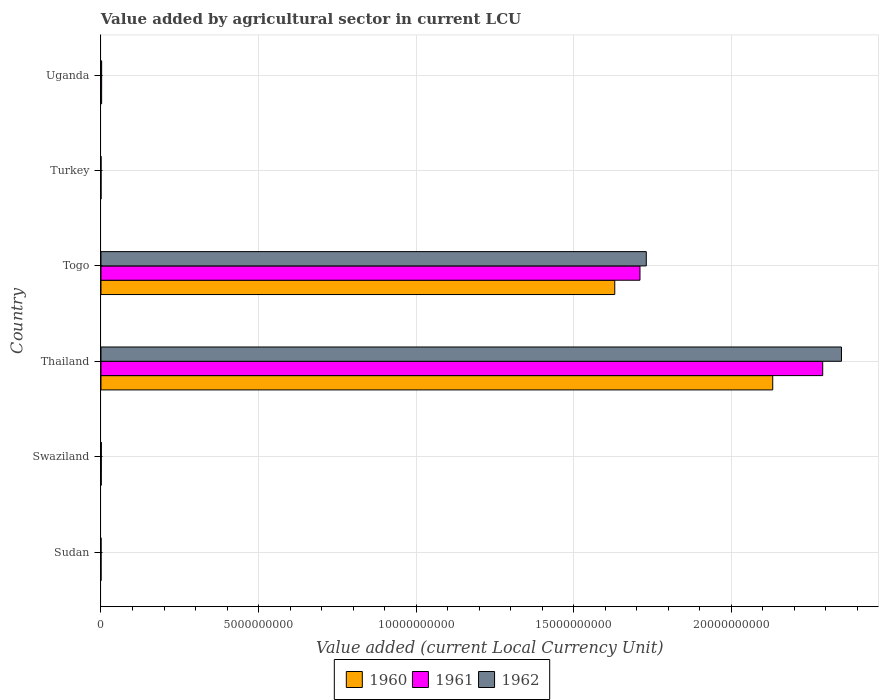How many different coloured bars are there?
Your answer should be very brief. 3. How many groups of bars are there?
Give a very brief answer. 6. Are the number of bars on each tick of the Y-axis equal?
Provide a succinct answer. Yes. How many bars are there on the 6th tick from the top?
Provide a succinct answer. 3. What is the label of the 4th group of bars from the top?
Make the answer very short. Thailand. In how many cases, is the number of bars for a given country not equal to the number of legend labels?
Make the answer very short. 0. What is the value added by agricultural sector in 1960 in Uganda?
Provide a short and direct response. 2.01e+07. Across all countries, what is the maximum value added by agricultural sector in 1962?
Your answer should be very brief. 2.35e+1. Across all countries, what is the minimum value added by agricultural sector in 1961?
Ensure brevity in your answer.  3.72e+04. In which country was the value added by agricultural sector in 1962 maximum?
Your answer should be compact. Thailand. What is the total value added by agricultural sector in 1962 in the graph?
Ensure brevity in your answer.  4.08e+1. What is the difference between the value added by agricultural sector in 1961 in Sudan and that in Swaziland?
Your response must be concise. -9.08e+06. What is the difference between the value added by agricultural sector in 1962 in Uganda and the value added by agricultural sector in 1960 in Turkey?
Offer a terse response. 2.10e+07. What is the average value added by agricultural sector in 1961 per country?
Provide a succinct answer. 6.67e+09. What is the difference between the value added by agricultural sector in 1960 and value added by agricultural sector in 1961 in Togo?
Make the answer very short. -8.00e+08. What is the ratio of the value added by agricultural sector in 1961 in Sudan to that in Togo?
Provide a short and direct response. 1.282456042854219e-5. Is the value added by agricultural sector in 1960 in Swaziland less than that in Thailand?
Your answer should be compact. Yes. What is the difference between the highest and the second highest value added by agricultural sector in 1962?
Your answer should be very brief. 6.19e+09. What is the difference between the highest and the lowest value added by agricultural sector in 1962?
Keep it short and to the point. 2.35e+1. What does the 1st bar from the top in Togo represents?
Offer a terse response. 1962. What does the 1st bar from the bottom in Thailand represents?
Ensure brevity in your answer.  1960. Is it the case that in every country, the sum of the value added by agricultural sector in 1960 and value added by agricultural sector in 1961 is greater than the value added by agricultural sector in 1962?
Offer a terse response. Yes. How many bars are there?
Give a very brief answer. 18. How many countries are there in the graph?
Your answer should be very brief. 6. Are the values on the major ticks of X-axis written in scientific E-notation?
Provide a short and direct response. No. Does the graph contain any zero values?
Provide a succinct answer. No. Where does the legend appear in the graph?
Ensure brevity in your answer.  Bottom center. How many legend labels are there?
Your answer should be compact. 3. How are the legend labels stacked?
Provide a short and direct response. Horizontal. What is the title of the graph?
Give a very brief answer. Value added by agricultural sector in current LCU. Does "1992" appear as one of the legend labels in the graph?
Your response must be concise. No. What is the label or title of the X-axis?
Provide a short and direct response. Value added (current Local Currency Unit). What is the Value added (current Local Currency Unit) of 1960 in Sudan?
Keep it short and to the point. 2.02e+05. What is the Value added (current Local Currency Unit) in 1961 in Sudan?
Offer a terse response. 2.19e+05. What is the Value added (current Local Currency Unit) of 1962 in Sudan?
Offer a terse response. 2.31e+05. What is the Value added (current Local Currency Unit) of 1960 in Swaziland?
Your answer should be very brief. 7.90e+06. What is the Value added (current Local Currency Unit) in 1961 in Swaziland?
Keep it short and to the point. 9.30e+06. What is the Value added (current Local Currency Unit) of 1962 in Swaziland?
Your answer should be very brief. 1.14e+07. What is the Value added (current Local Currency Unit) of 1960 in Thailand?
Give a very brief answer. 2.13e+1. What is the Value added (current Local Currency Unit) of 1961 in Thailand?
Keep it short and to the point. 2.29e+1. What is the Value added (current Local Currency Unit) in 1962 in Thailand?
Your response must be concise. 2.35e+1. What is the Value added (current Local Currency Unit) in 1960 in Togo?
Your answer should be very brief. 1.63e+1. What is the Value added (current Local Currency Unit) in 1961 in Togo?
Make the answer very short. 1.71e+1. What is the Value added (current Local Currency Unit) of 1962 in Togo?
Your answer should be compact. 1.73e+1. What is the Value added (current Local Currency Unit) of 1960 in Turkey?
Provide a short and direct response. 3.74e+04. What is the Value added (current Local Currency Unit) in 1961 in Turkey?
Provide a short and direct response. 3.72e+04. What is the Value added (current Local Currency Unit) in 1962 in Turkey?
Offer a terse response. 4.24e+04. What is the Value added (current Local Currency Unit) of 1960 in Uganda?
Keep it short and to the point. 2.01e+07. What is the Value added (current Local Currency Unit) in 1961 in Uganda?
Ensure brevity in your answer.  2.10e+07. What is the Value added (current Local Currency Unit) in 1962 in Uganda?
Keep it short and to the point. 2.11e+07. Across all countries, what is the maximum Value added (current Local Currency Unit) in 1960?
Your answer should be compact. 2.13e+1. Across all countries, what is the maximum Value added (current Local Currency Unit) of 1961?
Your answer should be very brief. 2.29e+1. Across all countries, what is the maximum Value added (current Local Currency Unit) in 1962?
Ensure brevity in your answer.  2.35e+1. Across all countries, what is the minimum Value added (current Local Currency Unit) in 1960?
Ensure brevity in your answer.  3.74e+04. Across all countries, what is the minimum Value added (current Local Currency Unit) in 1961?
Your response must be concise. 3.72e+04. Across all countries, what is the minimum Value added (current Local Currency Unit) in 1962?
Give a very brief answer. 4.24e+04. What is the total Value added (current Local Currency Unit) of 1960 in the graph?
Make the answer very short. 3.76e+1. What is the total Value added (current Local Currency Unit) of 1961 in the graph?
Ensure brevity in your answer.  4.00e+1. What is the total Value added (current Local Currency Unit) in 1962 in the graph?
Ensure brevity in your answer.  4.08e+1. What is the difference between the Value added (current Local Currency Unit) in 1960 in Sudan and that in Swaziland?
Your response must be concise. -7.70e+06. What is the difference between the Value added (current Local Currency Unit) in 1961 in Sudan and that in Swaziland?
Give a very brief answer. -9.08e+06. What is the difference between the Value added (current Local Currency Unit) of 1962 in Sudan and that in Swaziland?
Give a very brief answer. -1.12e+07. What is the difference between the Value added (current Local Currency Unit) in 1960 in Sudan and that in Thailand?
Keep it short and to the point. -2.13e+1. What is the difference between the Value added (current Local Currency Unit) of 1961 in Sudan and that in Thailand?
Your response must be concise. -2.29e+1. What is the difference between the Value added (current Local Currency Unit) in 1962 in Sudan and that in Thailand?
Your response must be concise. -2.35e+1. What is the difference between the Value added (current Local Currency Unit) of 1960 in Sudan and that in Togo?
Offer a very short reply. -1.63e+1. What is the difference between the Value added (current Local Currency Unit) in 1961 in Sudan and that in Togo?
Your answer should be compact. -1.71e+1. What is the difference between the Value added (current Local Currency Unit) in 1962 in Sudan and that in Togo?
Your answer should be compact. -1.73e+1. What is the difference between the Value added (current Local Currency Unit) of 1960 in Sudan and that in Turkey?
Offer a terse response. 1.64e+05. What is the difference between the Value added (current Local Currency Unit) in 1961 in Sudan and that in Turkey?
Your answer should be very brief. 1.82e+05. What is the difference between the Value added (current Local Currency Unit) of 1962 in Sudan and that in Turkey?
Your answer should be very brief. 1.88e+05. What is the difference between the Value added (current Local Currency Unit) of 1960 in Sudan and that in Uganda?
Give a very brief answer. -1.99e+07. What is the difference between the Value added (current Local Currency Unit) in 1961 in Sudan and that in Uganda?
Provide a short and direct response. -2.08e+07. What is the difference between the Value added (current Local Currency Unit) in 1962 in Sudan and that in Uganda?
Give a very brief answer. -2.08e+07. What is the difference between the Value added (current Local Currency Unit) of 1960 in Swaziland and that in Thailand?
Your answer should be very brief. -2.13e+1. What is the difference between the Value added (current Local Currency Unit) in 1961 in Swaziland and that in Thailand?
Your answer should be very brief. -2.29e+1. What is the difference between the Value added (current Local Currency Unit) of 1962 in Swaziland and that in Thailand?
Your response must be concise. -2.35e+1. What is the difference between the Value added (current Local Currency Unit) in 1960 in Swaziland and that in Togo?
Your answer should be compact. -1.63e+1. What is the difference between the Value added (current Local Currency Unit) in 1961 in Swaziland and that in Togo?
Keep it short and to the point. -1.71e+1. What is the difference between the Value added (current Local Currency Unit) in 1962 in Swaziland and that in Togo?
Give a very brief answer. -1.73e+1. What is the difference between the Value added (current Local Currency Unit) of 1960 in Swaziland and that in Turkey?
Your response must be concise. 7.86e+06. What is the difference between the Value added (current Local Currency Unit) in 1961 in Swaziland and that in Turkey?
Give a very brief answer. 9.26e+06. What is the difference between the Value added (current Local Currency Unit) in 1962 in Swaziland and that in Turkey?
Make the answer very short. 1.14e+07. What is the difference between the Value added (current Local Currency Unit) in 1960 in Swaziland and that in Uganda?
Offer a very short reply. -1.22e+07. What is the difference between the Value added (current Local Currency Unit) in 1961 in Swaziland and that in Uganda?
Provide a short and direct response. -1.17e+07. What is the difference between the Value added (current Local Currency Unit) in 1962 in Swaziland and that in Uganda?
Give a very brief answer. -9.67e+06. What is the difference between the Value added (current Local Currency Unit) in 1960 in Thailand and that in Togo?
Provide a short and direct response. 5.01e+09. What is the difference between the Value added (current Local Currency Unit) in 1961 in Thailand and that in Togo?
Your answer should be compact. 5.80e+09. What is the difference between the Value added (current Local Currency Unit) of 1962 in Thailand and that in Togo?
Your answer should be compact. 6.19e+09. What is the difference between the Value added (current Local Currency Unit) in 1960 in Thailand and that in Turkey?
Provide a short and direct response. 2.13e+1. What is the difference between the Value added (current Local Currency Unit) in 1961 in Thailand and that in Turkey?
Your answer should be very brief. 2.29e+1. What is the difference between the Value added (current Local Currency Unit) of 1962 in Thailand and that in Turkey?
Give a very brief answer. 2.35e+1. What is the difference between the Value added (current Local Currency Unit) in 1960 in Thailand and that in Uganda?
Your answer should be compact. 2.13e+1. What is the difference between the Value added (current Local Currency Unit) in 1961 in Thailand and that in Uganda?
Make the answer very short. 2.29e+1. What is the difference between the Value added (current Local Currency Unit) of 1962 in Thailand and that in Uganda?
Provide a short and direct response. 2.35e+1. What is the difference between the Value added (current Local Currency Unit) in 1960 in Togo and that in Turkey?
Offer a very short reply. 1.63e+1. What is the difference between the Value added (current Local Currency Unit) in 1961 in Togo and that in Turkey?
Offer a terse response. 1.71e+1. What is the difference between the Value added (current Local Currency Unit) in 1962 in Togo and that in Turkey?
Give a very brief answer. 1.73e+1. What is the difference between the Value added (current Local Currency Unit) of 1960 in Togo and that in Uganda?
Make the answer very short. 1.63e+1. What is the difference between the Value added (current Local Currency Unit) of 1961 in Togo and that in Uganda?
Your response must be concise. 1.71e+1. What is the difference between the Value added (current Local Currency Unit) of 1962 in Togo and that in Uganda?
Your answer should be very brief. 1.73e+1. What is the difference between the Value added (current Local Currency Unit) in 1960 in Turkey and that in Uganda?
Your response must be concise. -2.01e+07. What is the difference between the Value added (current Local Currency Unit) in 1961 in Turkey and that in Uganda?
Offer a terse response. -2.10e+07. What is the difference between the Value added (current Local Currency Unit) of 1962 in Turkey and that in Uganda?
Your response must be concise. -2.10e+07. What is the difference between the Value added (current Local Currency Unit) of 1960 in Sudan and the Value added (current Local Currency Unit) of 1961 in Swaziland?
Keep it short and to the point. -9.10e+06. What is the difference between the Value added (current Local Currency Unit) of 1960 in Sudan and the Value added (current Local Currency Unit) of 1962 in Swaziland?
Your answer should be compact. -1.12e+07. What is the difference between the Value added (current Local Currency Unit) of 1961 in Sudan and the Value added (current Local Currency Unit) of 1962 in Swaziland?
Provide a succinct answer. -1.12e+07. What is the difference between the Value added (current Local Currency Unit) of 1960 in Sudan and the Value added (current Local Currency Unit) of 1961 in Thailand?
Provide a short and direct response. -2.29e+1. What is the difference between the Value added (current Local Currency Unit) of 1960 in Sudan and the Value added (current Local Currency Unit) of 1962 in Thailand?
Give a very brief answer. -2.35e+1. What is the difference between the Value added (current Local Currency Unit) in 1961 in Sudan and the Value added (current Local Currency Unit) in 1962 in Thailand?
Your response must be concise. -2.35e+1. What is the difference between the Value added (current Local Currency Unit) of 1960 in Sudan and the Value added (current Local Currency Unit) of 1961 in Togo?
Make the answer very short. -1.71e+1. What is the difference between the Value added (current Local Currency Unit) of 1960 in Sudan and the Value added (current Local Currency Unit) of 1962 in Togo?
Offer a terse response. -1.73e+1. What is the difference between the Value added (current Local Currency Unit) in 1961 in Sudan and the Value added (current Local Currency Unit) in 1962 in Togo?
Provide a succinct answer. -1.73e+1. What is the difference between the Value added (current Local Currency Unit) of 1960 in Sudan and the Value added (current Local Currency Unit) of 1961 in Turkey?
Offer a very short reply. 1.64e+05. What is the difference between the Value added (current Local Currency Unit) of 1960 in Sudan and the Value added (current Local Currency Unit) of 1962 in Turkey?
Provide a short and direct response. 1.59e+05. What is the difference between the Value added (current Local Currency Unit) in 1961 in Sudan and the Value added (current Local Currency Unit) in 1962 in Turkey?
Provide a short and direct response. 1.77e+05. What is the difference between the Value added (current Local Currency Unit) in 1960 in Sudan and the Value added (current Local Currency Unit) in 1961 in Uganda?
Ensure brevity in your answer.  -2.08e+07. What is the difference between the Value added (current Local Currency Unit) in 1960 in Sudan and the Value added (current Local Currency Unit) in 1962 in Uganda?
Your answer should be very brief. -2.09e+07. What is the difference between the Value added (current Local Currency Unit) of 1961 in Sudan and the Value added (current Local Currency Unit) of 1962 in Uganda?
Give a very brief answer. -2.08e+07. What is the difference between the Value added (current Local Currency Unit) of 1960 in Swaziland and the Value added (current Local Currency Unit) of 1961 in Thailand?
Keep it short and to the point. -2.29e+1. What is the difference between the Value added (current Local Currency Unit) of 1960 in Swaziland and the Value added (current Local Currency Unit) of 1962 in Thailand?
Make the answer very short. -2.35e+1. What is the difference between the Value added (current Local Currency Unit) of 1961 in Swaziland and the Value added (current Local Currency Unit) of 1962 in Thailand?
Provide a succinct answer. -2.35e+1. What is the difference between the Value added (current Local Currency Unit) of 1960 in Swaziland and the Value added (current Local Currency Unit) of 1961 in Togo?
Your response must be concise. -1.71e+1. What is the difference between the Value added (current Local Currency Unit) of 1960 in Swaziland and the Value added (current Local Currency Unit) of 1962 in Togo?
Ensure brevity in your answer.  -1.73e+1. What is the difference between the Value added (current Local Currency Unit) in 1961 in Swaziland and the Value added (current Local Currency Unit) in 1962 in Togo?
Give a very brief answer. -1.73e+1. What is the difference between the Value added (current Local Currency Unit) in 1960 in Swaziland and the Value added (current Local Currency Unit) in 1961 in Turkey?
Your answer should be very brief. 7.86e+06. What is the difference between the Value added (current Local Currency Unit) of 1960 in Swaziland and the Value added (current Local Currency Unit) of 1962 in Turkey?
Offer a terse response. 7.86e+06. What is the difference between the Value added (current Local Currency Unit) of 1961 in Swaziland and the Value added (current Local Currency Unit) of 1962 in Turkey?
Make the answer very short. 9.26e+06. What is the difference between the Value added (current Local Currency Unit) of 1960 in Swaziland and the Value added (current Local Currency Unit) of 1961 in Uganda?
Ensure brevity in your answer.  -1.31e+07. What is the difference between the Value added (current Local Currency Unit) in 1960 in Swaziland and the Value added (current Local Currency Unit) in 1962 in Uganda?
Provide a short and direct response. -1.32e+07. What is the difference between the Value added (current Local Currency Unit) in 1961 in Swaziland and the Value added (current Local Currency Unit) in 1962 in Uganda?
Your response must be concise. -1.18e+07. What is the difference between the Value added (current Local Currency Unit) of 1960 in Thailand and the Value added (current Local Currency Unit) of 1961 in Togo?
Provide a succinct answer. 4.21e+09. What is the difference between the Value added (current Local Currency Unit) of 1960 in Thailand and the Value added (current Local Currency Unit) of 1962 in Togo?
Provide a succinct answer. 4.01e+09. What is the difference between the Value added (current Local Currency Unit) in 1961 in Thailand and the Value added (current Local Currency Unit) in 1962 in Togo?
Give a very brief answer. 5.60e+09. What is the difference between the Value added (current Local Currency Unit) in 1960 in Thailand and the Value added (current Local Currency Unit) in 1961 in Turkey?
Offer a terse response. 2.13e+1. What is the difference between the Value added (current Local Currency Unit) in 1960 in Thailand and the Value added (current Local Currency Unit) in 1962 in Turkey?
Your answer should be very brief. 2.13e+1. What is the difference between the Value added (current Local Currency Unit) of 1961 in Thailand and the Value added (current Local Currency Unit) of 1962 in Turkey?
Make the answer very short. 2.29e+1. What is the difference between the Value added (current Local Currency Unit) in 1960 in Thailand and the Value added (current Local Currency Unit) in 1961 in Uganda?
Make the answer very short. 2.13e+1. What is the difference between the Value added (current Local Currency Unit) in 1960 in Thailand and the Value added (current Local Currency Unit) in 1962 in Uganda?
Offer a terse response. 2.13e+1. What is the difference between the Value added (current Local Currency Unit) in 1961 in Thailand and the Value added (current Local Currency Unit) in 1962 in Uganda?
Make the answer very short. 2.29e+1. What is the difference between the Value added (current Local Currency Unit) of 1960 in Togo and the Value added (current Local Currency Unit) of 1961 in Turkey?
Give a very brief answer. 1.63e+1. What is the difference between the Value added (current Local Currency Unit) in 1960 in Togo and the Value added (current Local Currency Unit) in 1962 in Turkey?
Provide a short and direct response. 1.63e+1. What is the difference between the Value added (current Local Currency Unit) in 1961 in Togo and the Value added (current Local Currency Unit) in 1962 in Turkey?
Your answer should be very brief. 1.71e+1. What is the difference between the Value added (current Local Currency Unit) of 1960 in Togo and the Value added (current Local Currency Unit) of 1961 in Uganda?
Your answer should be very brief. 1.63e+1. What is the difference between the Value added (current Local Currency Unit) of 1960 in Togo and the Value added (current Local Currency Unit) of 1962 in Uganda?
Give a very brief answer. 1.63e+1. What is the difference between the Value added (current Local Currency Unit) of 1961 in Togo and the Value added (current Local Currency Unit) of 1962 in Uganda?
Make the answer very short. 1.71e+1. What is the difference between the Value added (current Local Currency Unit) in 1960 in Turkey and the Value added (current Local Currency Unit) in 1961 in Uganda?
Ensure brevity in your answer.  -2.10e+07. What is the difference between the Value added (current Local Currency Unit) in 1960 in Turkey and the Value added (current Local Currency Unit) in 1962 in Uganda?
Offer a very short reply. -2.10e+07. What is the difference between the Value added (current Local Currency Unit) in 1961 in Turkey and the Value added (current Local Currency Unit) in 1962 in Uganda?
Provide a succinct answer. -2.10e+07. What is the average Value added (current Local Currency Unit) of 1960 per country?
Your answer should be very brief. 6.27e+09. What is the average Value added (current Local Currency Unit) of 1961 per country?
Your response must be concise. 6.67e+09. What is the average Value added (current Local Currency Unit) in 1962 per country?
Offer a terse response. 6.80e+09. What is the difference between the Value added (current Local Currency Unit) of 1960 and Value added (current Local Currency Unit) of 1961 in Sudan?
Make the answer very short. -1.76e+04. What is the difference between the Value added (current Local Currency Unit) in 1960 and Value added (current Local Currency Unit) in 1962 in Sudan?
Make the answer very short. -2.90e+04. What is the difference between the Value added (current Local Currency Unit) of 1961 and Value added (current Local Currency Unit) of 1962 in Sudan?
Offer a terse response. -1.14e+04. What is the difference between the Value added (current Local Currency Unit) in 1960 and Value added (current Local Currency Unit) in 1961 in Swaziland?
Your answer should be compact. -1.40e+06. What is the difference between the Value added (current Local Currency Unit) in 1960 and Value added (current Local Currency Unit) in 1962 in Swaziland?
Offer a terse response. -3.50e+06. What is the difference between the Value added (current Local Currency Unit) in 1961 and Value added (current Local Currency Unit) in 1962 in Swaziland?
Give a very brief answer. -2.10e+06. What is the difference between the Value added (current Local Currency Unit) in 1960 and Value added (current Local Currency Unit) in 1961 in Thailand?
Your answer should be very brief. -1.59e+09. What is the difference between the Value added (current Local Currency Unit) in 1960 and Value added (current Local Currency Unit) in 1962 in Thailand?
Provide a succinct answer. -2.18e+09. What is the difference between the Value added (current Local Currency Unit) in 1961 and Value added (current Local Currency Unit) in 1962 in Thailand?
Your answer should be very brief. -5.95e+08. What is the difference between the Value added (current Local Currency Unit) of 1960 and Value added (current Local Currency Unit) of 1961 in Togo?
Your response must be concise. -8.00e+08. What is the difference between the Value added (current Local Currency Unit) of 1960 and Value added (current Local Currency Unit) of 1962 in Togo?
Keep it short and to the point. -1.00e+09. What is the difference between the Value added (current Local Currency Unit) of 1961 and Value added (current Local Currency Unit) of 1962 in Togo?
Your answer should be very brief. -2.00e+08. What is the difference between the Value added (current Local Currency Unit) in 1960 and Value added (current Local Currency Unit) in 1961 in Turkey?
Ensure brevity in your answer.  200. What is the difference between the Value added (current Local Currency Unit) of 1960 and Value added (current Local Currency Unit) of 1962 in Turkey?
Ensure brevity in your answer.  -5000. What is the difference between the Value added (current Local Currency Unit) in 1961 and Value added (current Local Currency Unit) in 1962 in Turkey?
Keep it short and to the point. -5200. What is the difference between the Value added (current Local Currency Unit) of 1960 and Value added (current Local Currency Unit) of 1961 in Uganda?
Keep it short and to the point. -9.01e+05. What is the difference between the Value added (current Local Currency Unit) in 1960 and Value added (current Local Currency Unit) in 1962 in Uganda?
Offer a very short reply. -9.40e+05. What is the difference between the Value added (current Local Currency Unit) in 1961 and Value added (current Local Currency Unit) in 1962 in Uganda?
Your answer should be compact. -3.88e+04. What is the ratio of the Value added (current Local Currency Unit) in 1960 in Sudan to that in Swaziland?
Keep it short and to the point. 0.03. What is the ratio of the Value added (current Local Currency Unit) in 1961 in Sudan to that in Swaziland?
Provide a succinct answer. 0.02. What is the ratio of the Value added (current Local Currency Unit) of 1962 in Sudan to that in Swaziland?
Your answer should be very brief. 0.02. What is the ratio of the Value added (current Local Currency Unit) in 1960 in Sudan to that in Turkey?
Your response must be concise. 5.39. What is the ratio of the Value added (current Local Currency Unit) of 1961 in Sudan to that in Turkey?
Provide a succinct answer. 5.9. What is the ratio of the Value added (current Local Currency Unit) of 1962 in Sudan to that in Turkey?
Ensure brevity in your answer.  5.44. What is the ratio of the Value added (current Local Currency Unit) of 1961 in Sudan to that in Uganda?
Offer a very short reply. 0.01. What is the ratio of the Value added (current Local Currency Unit) of 1962 in Sudan to that in Uganda?
Give a very brief answer. 0.01. What is the ratio of the Value added (current Local Currency Unit) of 1961 in Swaziland to that in Thailand?
Provide a short and direct response. 0. What is the ratio of the Value added (current Local Currency Unit) in 1962 in Swaziland to that in Thailand?
Provide a short and direct response. 0. What is the ratio of the Value added (current Local Currency Unit) of 1962 in Swaziland to that in Togo?
Provide a short and direct response. 0. What is the ratio of the Value added (current Local Currency Unit) of 1960 in Swaziland to that in Turkey?
Offer a very short reply. 211.23. What is the ratio of the Value added (current Local Currency Unit) of 1961 in Swaziland to that in Turkey?
Ensure brevity in your answer.  250. What is the ratio of the Value added (current Local Currency Unit) of 1962 in Swaziland to that in Turkey?
Your answer should be compact. 268.87. What is the ratio of the Value added (current Local Currency Unit) of 1960 in Swaziland to that in Uganda?
Offer a very short reply. 0.39. What is the ratio of the Value added (current Local Currency Unit) of 1961 in Swaziland to that in Uganda?
Ensure brevity in your answer.  0.44. What is the ratio of the Value added (current Local Currency Unit) of 1962 in Swaziland to that in Uganda?
Give a very brief answer. 0.54. What is the ratio of the Value added (current Local Currency Unit) in 1960 in Thailand to that in Togo?
Your answer should be very brief. 1.31. What is the ratio of the Value added (current Local Currency Unit) in 1961 in Thailand to that in Togo?
Provide a succinct answer. 1.34. What is the ratio of the Value added (current Local Currency Unit) in 1962 in Thailand to that in Togo?
Your response must be concise. 1.36. What is the ratio of the Value added (current Local Currency Unit) in 1960 in Thailand to that in Turkey?
Your answer should be compact. 5.70e+05. What is the ratio of the Value added (current Local Currency Unit) in 1961 in Thailand to that in Turkey?
Give a very brief answer. 6.16e+05. What is the ratio of the Value added (current Local Currency Unit) of 1962 in Thailand to that in Turkey?
Your response must be concise. 5.54e+05. What is the ratio of the Value added (current Local Currency Unit) of 1960 in Thailand to that in Uganda?
Give a very brief answer. 1058.87. What is the ratio of the Value added (current Local Currency Unit) in 1961 in Thailand to that in Uganda?
Ensure brevity in your answer.  1088.91. What is the ratio of the Value added (current Local Currency Unit) of 1962 in Thailand to that in Uganda?
Your answer should be very brief. 1115.13. What is the ratio of the Value added (current Local Currency Unit) of 1960 in Togo to that in Turkey?
Provide a succinct answer. 4.36e+05. What is the ratio of the Value added (current Local Currency Unit) in 1961 in Togo to that in Turkey?
Provide a short and direct response. 4.60e+05. What is the ratio of the Value added (current Local Currency Unit) in 1962 in Togo to that in Turkey?
Make the answer very short. 4.08e+05. What is the ratio of the Value added (current Local Currency Unit) of 1960 in Togo to that in Uganda?
Your response must be concise. 809.86. What is the ratio of the Value added (current Local Currency Unit) in 1961 in Togo to that in Uganda?
Keep it short and to the point. 813.19. What is the ratio of the Value added (current Local Currency Unit) of 1962 in Togo to that in Uganda?
Make the answer very short. 821.19. What is the ratio of the Value added (current Local Currency Unit) in 1960 in Turkey to that in Uganda?
Ensure brevity in your answer.  0. What is the ratio of the Value added (current Local Currency Unit) of 1961 in Turkey to that in Uganda?
Offer a terse response. 0. What is the ratio of the Value added (current Local Currency Unit) in 1962 in Turkey to that in Uganda?
Give a very brief answer. 0. What is the difference between the highest and the second highest Value added (current Local Currency Unit) of 1960?
Keep it short and to the point. 5.01e+09. What is the difference between the highest and the second highest Value added (current Local Currency Unit) in 1961?
Provide a succinct answer. 5.80e+09. What is the difference between the highest and the second highest Value added (current Local Currency Unit) of 1962?
Ensure brevity in your answer.  6.19e+09. What is the difference between the highest and the lowest Value added (current Local Currency Unit) of 1960?
Keep it short and to the point. 2.13e+1. What is the difference between the highest and the lowest Value added (current Local Currency Unit) in 1961?
Your answer should be very brief. 2.29e+1. What is the difference between the highest and the lowest Value added (current Local Currency Unit) of 1962?
Ensure brevity in your answer.  2.35e+1. 